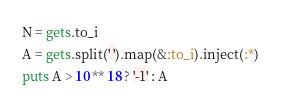<code> <loc_0><loc_0><loc_500><loc_500><_Ruby_>N = gets.to_i
A = gets.split(' ').map(&:to_i).inject(:*)
puts A > 10 ** 18 ? '-1' : A</code> 